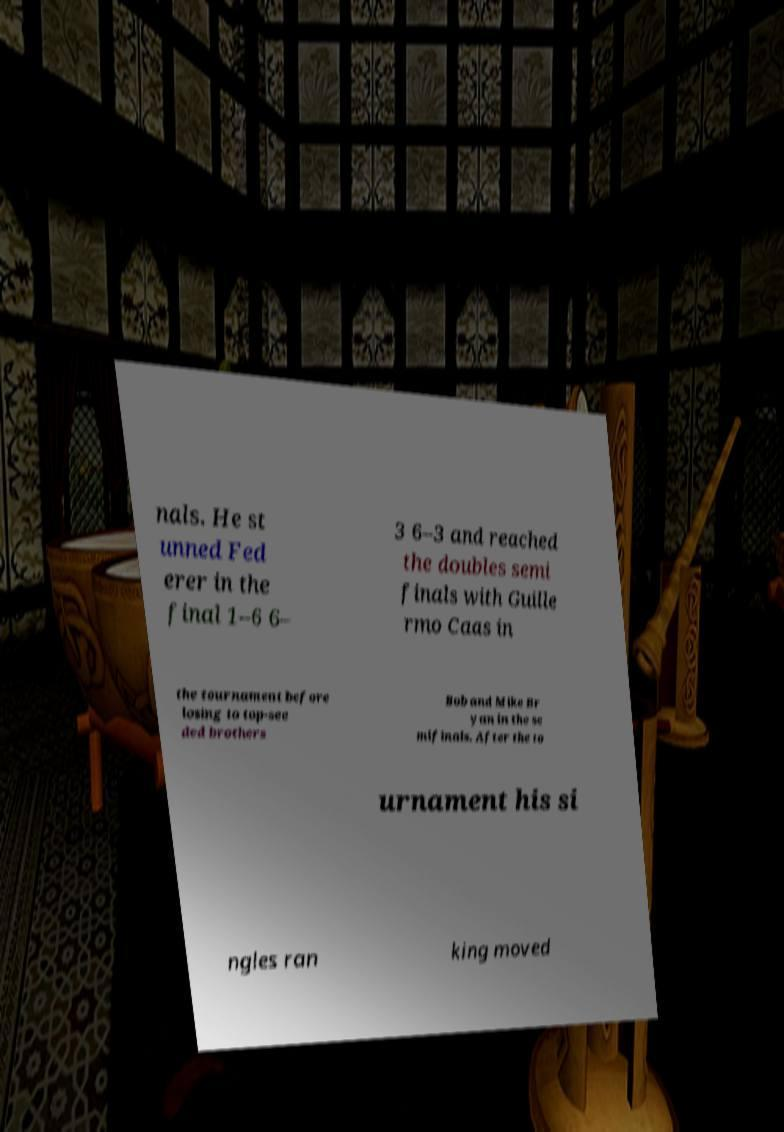Could you assist in decoding the text presented in this image and type it out clearly? nals. He st unned Fed erer in the final 1–6 6– 3 6–3 and reached the doubles semi finals with Guille rmo Caas in the tournament before losing to top-see ded brothers Bob and Mike Br yan in the se mifinals. After the to urnament his si ngles ran king moved 